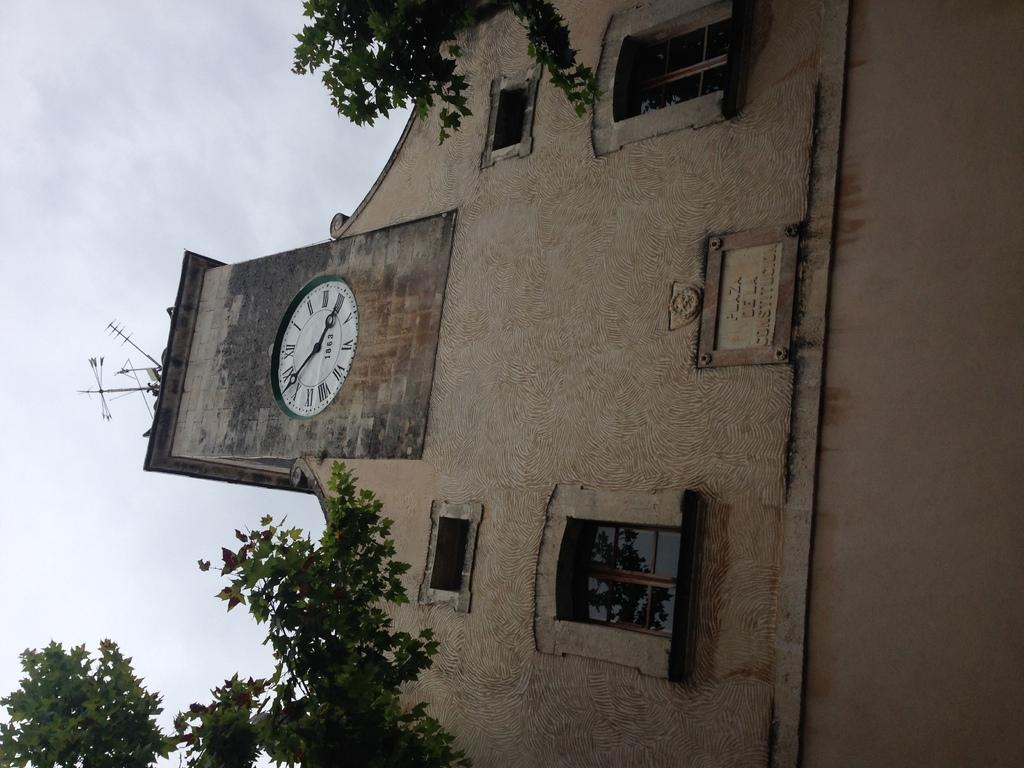<image>
Summarize the visual content of the image. A clock that shows it to be seven until four with 1863 on the clock face. 